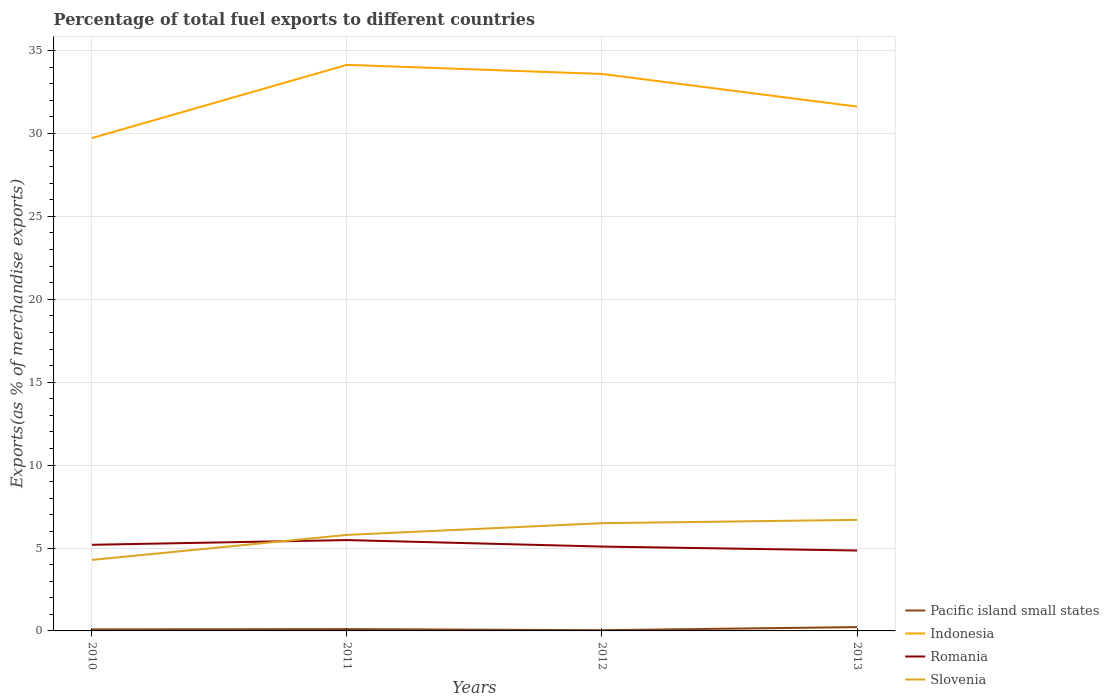Does the line corresponding to Slovenia intersect with the line corresponding to Indonesia?
Keep it short and to the point. No. Is the number of lines equal to the number of legend labels?
Ensure brevity in your answer.  Yes. Across all years, what is the maximum percentage of exports to different countries in Indonesia?
Your answer should be very brief. 29.73. What is the total percentage of exports to different countries in Slovenia in the graph?
Your response must be concise. -1.51. What is the difference between the highest and the second highest percentage of exports to different countries in Romania?
Provide a short and direct response. 0.63. Is the percentage of exports to different countries in Pacific island small states strictly greater than the percentage of exports to different countries in Slovenia over the years?
Offer a very short reply. Yes. How many years are there in the graph?
Keep it short and to the point. 4. Does the graph contain grids?
Provide a short and direct response. Yes. How are the legend labels stacked?
Your answer should be very brief. Vertical. What is the title of the graph?
Ensure brevity in your answer.  Percentage of total fuel exports to different countries. Does "Middle East & North Africa (developing only)" appear as one of the legend labels in the graph?
Ensure brevity in your answer.  No. What is the label or title of the Y-axis?
Give a very brief answer. Exports(as % of merchandise exports). What is the Exports(as % of merchandise exports) of Pacific island small states in 2010?
Offer a terse response. 0.09. What is the Exports(as % of merchandise exports) in Indonesia in 2010?
Your answer should be compact. 29.73. What is the Exports(as % of merchandise exports) of Romania in 2010?
Provide a short and direct response. 5.2. What is the Exports(as % of merchandise exports) in Slovenia in 2010?
Your response must be concise. 4.28. What is the Exports(as % of merchandise exports) in Pacific island small states in 2011?
Keep it short and to the point. 0.11. What is the Exports(as % of merchandise exports) in Indonesia in 2011?
Offer a terse response. 34.14. What is the Exports(as % of merchandise exports) in Romania in 2011?
Give a very brief answer. 5.48. What is the Exports(as % of merchandise exports) in Slovenia in 2011?
Give a very brief answer. 5.79. What is the Exports(as % of merchandise exports) of Pacific island small states in 2012?
Make the answer very short. 0.04. What is the Exports(as % of merchandise exports) of Indonesia in 2012?
Make the answer very short. 33.59. What is the Exports(as % of merchandise exports) of Romania in 2012?
Provide a short and direct response. 5.09. What is the Exports(as % of merchandise exports) in Slovenia in 2012?
Give a very brief answer. 6.5. What is the Exports(as % of merchandise exports) of Pacific island small states in 2013?
Give a very brief answer. 0.23. What is the Exports(as % of merchandise exports) of Indonesia in 2013?
Your answer should be compact. 31.62. What is the Exports(as % of merchandise exports) of Romania in 2013?
Give a very brief answer. 4.85. What is the Exports(as % of merchandise exports) in Slovenia in 2013?
Offer a terse response. 6.7. Across all years, what is the maximum Exports(as % of merchandise exports) in Pacific island small states?
Provide a succinct answer. 0.23. Across all years, what is the maximum Exports(as % of merchandise exports) in Indonesia?
Give a very brief answer. 34.14. Across all years, what is the maximum Exports(as % of merchandise exports) in Romania?
Make the answer very short. 5.48. Across all years, what is the maximum Exports(as % of merchandise exports) in Slovenia?
Your answer should be compact. 6.7. Across all years, what is the minimum Exports(as % of merchandise exports) in Pacific island small states?
Your answer should be very brief. 0.04. Across all years, what is the minimum Exports(as % of merchandise exports) in Indonesia?
Give a very brief answer. 29.73. Across all years, what is the minimum Exports(as % of merchandise exports) of Romania?
Your response must be concise. 4.85. Across all years, what is the minimum Exports(as % of merchandise exports) of Slovenia?
Provide a short and direct response. 4.28. What is the total Exports(as % of merchandise exports) of Pacific island small states in the graph?
Provide a short and direct response. 0.47. What is the total Exports(as % of merchandise exports) of Indonesia in the graph?
Your answer should be very brief. 129.08. What is the total Exports(as % of merchandise exports) in Romania in the graph?
Provide a short and direct response. 20.61. What is the total Exports(as % of merchandise exports) in Slovenia in the graph?
Offer a terse response. 23.27. What is the difference between the Exports(as % of merchandise exports) in Pacific island small states in 2010 and that in 2011?
Keep it short and to the point. -0.02. What is the difference between the Exports(as % of merchandise exports) in Indonesia in 2010 and that in 2011?
Ensure brevity in your answer.  -4.41. What is the difference between the Exports(as % of merchandise exports) in Romania in 2010 and that in 2011?
Your answer should be compact. -0.28. What is the difference between the Exports(as % of merchandise exports) in Slovenia in 2010 and that in 2011?
Ensure brevity in your answer.  -1.51. What is the difference between the Exports(as % of merchandise exports) of Pacific island small states in 2010 and that in 2012?
Provide a succinct answer. 0.05. What is the difference between the Exports(as % of merchandise exports) in Indonesia in 2010 and that in 2012?
Your answer should be compact. -3.86. What is the difference between the Exports(as % of merchandise exports) in Romania in 2010 and that in 2012?
Make the answer very short. 0.11. What is the difference between the Exports(as % of merchandise exports) of Slovenia in 2010 and that in 2012?
Make the answer very short. -2.21. What is the difference between the Exports(as % of merchandise exports) in Pacific island small states in 2010 and that in 2013?
Your answer should be compact. -0.14. What is the difference between the Exports(as % of merchandise exports) in Indonesia in 2010 and that in 2013?
Your response must be concise. -1.9. What is the difference between the Exports(as % of merchandise exports) of Romania in 2010 and that in 2013?
Offer a terse response. 0.35. What is the difference between the Exports(as % of merchandise exports) of Slovenia in 2010 and that in 2013?
Keep it short and to the point. -2.41. What is the difference between the Exports(as % of merchandise exports) of Pacific island small states in 2011 and that in 2012?
Keep it short and to the point. 0.07. What is the difference between the Exports(as % of merchandise exports) in Indonesia in 2011 and that in 2012?
Provide a succinct answer. 0.55. What is the difference between the Exports(as % of merchandise exports) in Romania in 2011 and that in 2012?
Offer a very short reply. 0.39. What is the difference between the Exports(as % of merchandise exports) in Slovenia in 2011 and that in 2012?
Your answer should be compact. -0.71. What is the difference between the Exports(as % of merchandise exports) in Pacific island small states in 2011 and that in 2013?
Your answer should be compact. -0.12. What is the difference between the Exports(as % of merchandise exports) in Indonesia in 2011 and that in 2013?
Provide a succinct answer. 2.52. What is the difference between the Exports(as % of merchandise exports) in Romania in 2011 and that in 2013?
Give a very brief answer. 0.63. What is the difference between the Exports(as % of merchandise exports) of Slovenia in 2011 and that in 2013?
Your response must be concise. -0.91. What is the difference between the Exports(as % of merchandise exports) of Pacific island small states in 2012 and that in 2013?
Provide a succinct answer. -0.19. What is the difference between the Exports(as % of merchandise exports) in Indonesia in 2012 and that in 2013?
Your response must be concise. 1.97. What is the difference between the Exports(as % of merchandise exports) in Romania in 2012 and that in 2013?
Your answer should be compact. 0.24. What is the difference between the Exports(as % of merchandise exports) in Slovenia in 2012 and that in 2013?
Offer a terse response. -0.2. What is the difference between the Exports(as % of merchandise exports) of Pacific island small states in 2010 and the Exports(as % of merchandise exports) of Indonesia in 2011?
Your answer should be compact. -34.05. What is the difference between the Exports(as % of merchandise exports) of Pacific island small states in 2010 and the Exports(as % of merchandise exports) of Romania in 2011?
Your answer should be very brief. -5.39. What is the difference between the Exports(as % of merchandise exports) in Pacific island small states in 2010 and the Exports(as % of merchandise exports) in Slovenia in 2011?
Ensure brevity in your answer.  -5.7. What is the difference between the Exports(as % of merchandise exports) of Indonesia in 2010 and the Exports(as % of merchandise exports) of Romania in 2011?
Provide a succinct answer. 24.25. What is the difference between the Exports(as % of merchandise exports) in Indonesia in 2010 and the Exports(as % of merchandise exports) in Slovenia in 2011?
Your answer should be compact. 23.94. What is the difference between the Exports(as % of merchandise exports) in Romania in 2010 and the Exports(as % of merchandise exports) in Slovenia in 2011?
Give a very brief answer. -0.6. What is the difference between the Exports(as % of merchandise exports) of Pacific island small states in 2010 and the Exports(as % of merchandise exports) of Indonesia in 2012?
Ensure brevity in your answer.  -33.5. What is the difference between the Exports(as % of merchandise exports) of Pacific island small states in 2010 and the Exports(as % of merchandise exports) of Romania in 2012?
Your answer should be compact. -5. What is the difference between the Exports(as % of merchandise exports) of Pacific island small states in 2010 and the Exports(as % of merchandise exports) of Slovenia in 2012?
Provide a succinct answer. -6.41. What is the difference between the Exports(as % of merchandise exports) in Indonesia in 2010 and the Exports(as % of merchandise exports) in Romania in 2012?
Offer a terse response. 24.64. What is the difference between the Exports(as % of merchandise exports) in Indonesia in 2010 and the Exports(as % of merchandise exports) in Slovenia in 2012?
Give a very brief answer. 23.23. What is the difference between the Exports(as % of merchandise exports) of Romania in 2010 and the Exports(as % of merchandise exports) of Slovenia in 2012?
Offer a terse response. -1.3. What is the difference between the Exports(as % of merchandise exports) in Pacific island small states in 2010 and the Exports(as % of merchandise exports) in Indonesia in 2013?
Offer a very short reply. -31.53. What is the difference between the Exports(as % of merchandise exports) in Pacific island small states in 2010 and the Exports(as % of merchandise exports) in Romania in 2013?
Offer a terse response. -4.76. What is the difference between the Exports(as % of merchandise exports) of Pacific island small states in 2010 and the Exports(as % of merchandise exports) of Slovenia in 2013?
Offer a terse response. -6.61. What is the difference between the Exports(as % of merchandise exports) in Indonesia in 2010 and the Exports(as % of merchandise exports) in Romania in 2013?
Keep it short and to the point. 24.88. What is the difference between the Exports(as % of merchandise exports) of Indonesia in 2010 and the Exports(as % of merchandise exports) of Slovenia in 2013?
Offer a terse response. 23.03. What is the difference between the Exports(as % of merchandise exports) in Romania in 2010 and the Exports(as % of merchandise exports) in Slovenia in 2013?
Provide a short and direct response. -1.5. What is the difference between the Exports(as % of merchandise exports) in Pacific island small states in 2011 and the Exports(as % of merchandise exports) in Indonesia in 2012?
Offer a very short reply. -33.48. What is the difference between the Exports(as % of merchandise exports) of Pacific island small states in 2011 and the Exports(as % of merchandise exports) of Romania in 2012?
Your answer should be very brief. -4.98. What is the difference between the Exports(as % of merchandise exports) of Pacific island small states in 2011 and the Exports(as % of merchandise exports) of Slovenia in 2012?
Make the answer very short. -6.39. What is the difference between the Exports(as % of merchandise exports) of Indonesia in 2011 and the Exports(as % of merchandise exports) of Romania in 2012?
Provide a short and direct response. 29.05. What is the difference between the Exports(as % of merchandise exports) of Indonesia in 2011 and the Exports(as % of merchandise exports) of Slovenia in 2012?
Your response must be concise. 27.64. What is the difference between the Exports(as % of merchandise exports) in Romania in 2011 and the Exports(as % of merchandise exports) in Slovenia in 2012?
Offer a terse response. -1.02. What is the difference between the Exports(as % of merchandise exports) in Pacific island small states in 2011 and the Exports(as % of merchandise exports) in Indonesia in 2013?
Your response must be concise. -31.51. What is the difference between the Exports(as % of merchandise exports) in Pacific island small states in 2011 and the Exports(as % of merchandise exports) in Romania in 2013?
Keep it short and to the point. -4.74. What is the difference between the Exports(as % of merchandise exports) in Pacific island small states in 2011 and the Exports(as % of merchandise exports) in Slovenia in 2013?
Keep it short and to the point. -6.59. What is the difference between the Exports(as % of merchandise exports) in Indonesia in 2011 and the Exports(as % of merchandise exports) in Romania in 2013?
Your answer should be very brief. 29.29. What is the difference between the Exports(as % of merchandise exports) of Indonesia in 2011 and the Exports(as % of merchandise exports) of Slovenia in 2013?
Ensure brevity in your answer.  27.44. What is the difference between the Exports(as % of merchandise exports) of Romania in 2011 and the Exports(as % of merchandise exports) of Slovenia in 2013?
Give a very brief answer. -1.22. What is the difference between the Exports(as % of merchandise exports) of Pacific island small states in 2012 and the Exports(as % of merchandise exports) of Indonesia in 2013?
Offer a very short reply. -31.58. What is the difference between the Exports(as % of merchandise exports) of Pacific island small states in 2012 and the Exports(as % of merchandise exports) of Romania in 2013?
Ensure brevity in your answer.  -4.81. What is the difference between the Exports(as % of merchandise exports) in Pacific island small states in 2012 and the Exports(as % of merchandise exports) in Slovenia in 2013?
Keep it short and to the point. -6.65. What is the difference between the Exports(as % of merchandise exports) in Indonesia in 2012 and the Exports(as % of merchandise exports) in Romania in 2013?
Make the answer very short. 28.74. What is the difference between the Exports(as % of merchandise exports) in Indonesia in 2012 and the Exports(as % of merchandise exports) in Slovenia in 2013?
Offer a terse response. 26.89. What is the difference between the Exports(as % of merchandise exports) of Romania in 2012 and the Exports(as % of merchandise exports) of Slovenia in 2013?
Provide a succinct answer. -1.61. What is the average Exports(as % of merchandise exports) in Pacific island small states per year?
Provide a succinct answer. 0.12. What is the average Exports(as % of merchandise exports) in Indonesia per year?
Your answer should be compact. 32.27. What is the average Exports(as % of merchandise exports) in Romania per year?
Give a very brief answer. 5.15. What is the average Exports(as % of merchandise exports) in Slovenia per year?
Offer a terse response. 5.82. In the year 2010, what is the difference between the Exports(as % of merchandise exports) of Pacific island small states and Exports(as % of merchandise exports) of Indonesia?
Keep it short and to the point. -29.64. In the year 2010, what is the difference between the Exports(as % of merchandise exports) in Pacific island small states and Exports(as % of merchandise exports) in Romania?
Your response must be concise. -5.11. In the year 2010, what is the difference between the Exports(as % of merchandise exports) of Pacific island small states and Exports(as % of merchandise exports) of Slovenia?
Your response must be concise. -4.19. In the year 2010, what is the difference between the Exports(as % of merchandise exports) of Indonesia and Exports(as % of merchandise exports) of Romania?
Your answer should be very brief. 24.53. In the year 2010, what is the difference between the Exports(as % of merchandise exports) of Indonesia and Exports(as % of merchandise exports) of Slovenia?
Offer a very short reply. 25.44. In the year 2010, what is the difference between the Exports(as % of merchandise exports) of Romania and Exports(as % of merchandise exports) of Slovenia?
Make the answer very short. 0.91. In the year 2011, what is the difference between the Exports(as % of merchandise exports) of Pacific island small states and Exports(as % of merchandise exports) of Indonesia?
Offer a terse response. -34.03. In the year 2011, what is the difference between the Exports(as % of merchandise exports) in Pacific island small states and Exports(as % of merchandise exports) in Romania?
Offer a very short reply. -5.37. In the year 2011, what is the difference between the Exports(as % of merchandise exports) of Pacific island small states and Exports(as % of merchandise exports) of Slovenia?
Your response must be concise. -5.68. In the year 2011, what is the difference between the Exports(as % of merchandise exports) of Indonesia and Exports(as % of merchandise exports) of Romania?
Your answer should be compact. 28.66. In the year 2011, what is the difference between the Exports(as % of merchandise exports) in Indonesia and Exports(as % of merchandise exports) in Slovenia?
Give a very brief answer. 28.35. In the year 2011, what is the difference between the Exports(as % of merchandise exports) of Romania and Exports(as % of merchandise exports) of Slovenia?
Your answer should be compact. -0.31. In the year 2012, what is the difference between the Exports(as % of merchandise exports) of Pacific island small states and Exports(as % of merchandise exports) of Indonesia?
Make the answer very short. -33.55. In the year 2012, what is the difference between the Exports(as % of merchandise exports) of Pacific island small states and Exports(as % of merchandise exports) of Romania?
Ensure brevity in your answer.  -5.04. In the year 2012, what is the difference between the Exports(as % of merchandise exports) of Pacific island small states and Exports(as % of merchandise exports) of Slovenia?
Offer a terse response. -6.45. In the year 2012, what is the difference between the Exports(as % of merchandise exports) of Indonesia and Exports(as % of merchandise exports) of Romania?
Provide a succinct answer. 28.5. In the year 2012, what is the difference between the Exports(as % of merchandise exports) in Indonesia and Exports(as % of merchandise exports) in Slovenia?
Offer a very short reply. 27.09. In the year 2012, what is the difference between the Exports(as % of merchandise exports) of Romania and Exports(as % of merchandise exports) of Slovenia?
Ensure brevity in your answer.  -1.41. In the year 2013, what is the difference between the Exports(as % of merchandise exports) of Pacific island small states and Exports(as % of merchandise exports) of Indonesia?
Ensure brevity in your answer.  -31.39. In the year 2013, what is the difference between the Exports(as % of merchandise exports) in Pacific island small states and Exports(as % of merchandise exports) in Romania?
Offer a terse response. -4.62. In the year 2013, what is the difference between the Exports(as % of merchandise exports) in Pacific island small states and Exports(as % of merchandise exports) in Slovenia?
Your answer should be very brief. -6.47. In the year 2013, what is the difference between the Exports(as % of merchandise exports) of Indonesia and Exports(as % of merchandise exports) of Romania?
Ensure brevity in your answer.  26.77. In the year 2013, what is the difference between the Exports(as % of merchandise exports) of Indonesia and Exports(as % of merchandise exports) of Slovenia?
Your response must be concise. 24.93. In the year 2013, what is the difference between the Exports(as % of merchandise exports) in Romania and Exports(as % of merchandise exports) in Slovenia?
Offer a very short reply. -1.85. What is the ratio of the Exports(as % of merchandise exports) in Pacific island small states in 2010 to that in 2011?
Keep it short and to the point. 0.82. What is the ratio of the Exports(as % of merchandise exports) of Indonesia in 2010 to that in 2011?
Offer a very short reply. 0.87. What is the ratio of the Exports(as % of merchandise exports) of Romania in 2010 to that in 2011?
Offer a very short reply. 0.95. What is the ratio of the Exports(as % of merchandise exports) of Slovenia in 2010 to that in 2011?
Make the answer very short. 0.74. What is the ratio of the Exports(as % of merchandise exports) of Pacific island small states in 2010 to that in 2012?
Ensure brevity in your answer.  2.11. What is the ratio of the Exports(as % of merchandise exports) in Indonesia in 2010 to that in 2012?
Ensure brevity in your answer.  0.89. What is the ratio of the Exports(as % of merchandise exports) of Romania in 2010 to that in 2012?
Your answer should be compact. 1.02. What is the ratio of the Exports(as % of merchandise exports) in Slovenia in 2010 to that in 2012?
Ensure brevity in your answer.  0.66. What is the ratio of the Exports(as % of merchandise exports) in Pacific island small states in 2010 to that in 2013?
Ensure brevity in your answer.  0.39. What is the ratio of the Exports(as % of merchandise exports) in Indonesia in 2010 to that in 2013?
Provide a succinct answer. 0.94. What is the ratio of the Exports(as % of merchandise exports) in Romania in 2010 to that in 2013?
Your response must be concise. 1.07. What is the ratio of the Exports(as % of merchandise exports) in Slovenia in 2010 to that in 2013?
Provide a short and direct response. 0.64. What is the ratio of the Exports(as % of merchandise exports) of Pacific island small states in 2011 to that in 2012?
Your answer should be compact. 2.58. What is the ratio of the Exports(as % of merchandise exports) of Indonesia in 2011 to that in 2012?
Give a very brief answer. 1.02. What is the ratio of the Exports(as % of merchandise exports) of Romania in 2011 to that in 2012?
Your answer should be very brief. 1.08. What is the ratio of the Exports(as % of merchandise exports) in Slovenia in 2011 to that in 2012?
Provide a short and direct response. 0.89. What is the ratio of the Exports(as % of merchandise exports) of Pacific island small states in 2011 to that in 2013?
Your answer should be very brief. 0.48. What is the ratio of the Exports(as % of merchandise exports) of Indonesia in 2011 to that in 2013?
Keep it short and to the point. 1.08. What is the ratio of the Exports(as % of merchandise exports) of Romania in 2011 to that in 2013?
Provide a short and direct response. 1.13. What is the ratio of the Exports(as % of merchandise exports) of Slovenia in 2011 to that in 2013?
Offer a terse response. 0.86. What is the ratio of the Exports(as % of merchandise exports) of Pacific island small states in 2012 to that in 2013?
Your answer should be compact. 0.19. What is the ratio of the Exports(as % of merchandise exports) in Indonesia in 2012 to that in 2013?
Offer a terse response. 1.06. What is the ratio of the Exports(as % of merchandise exports) in Romania in 2012 to that in 2013?
Your answer should be compact. 1.05. What is the ratio of the Exports(as % of merchandise exports) of Slovenia in 2012 to that in 2013?
Offer a terse response. 0.97. What is the difference between the highest and the second highest Exports(as % of merchandise exports) of Pacific island small states?
Provide a short and direct response. 0.12. What is the difference between the highest and the second highest Exports(as % of merchandise exports) of Indonesia?
Make the answer very short. 0.55. What is the difference between the highest and the second highest Exports(as % of merchandise exports) of Romania?
Your answer should be very brief. 0.28. What is the difference between the highest and the second highest Exports(as % of merchandise exports) in Slovenia?
Offer a terse response. 0.2. What is the difference between the highest and the lowest Exports(as % of merchandise exports) of Pacific island small states?
Offer a very short reply. 0.19. What is the difference between the highest and the lowest Exports(as % of merchandise exports) of Indonesia?
Give a very brief answer. 4.41. What is the difference between the highest and the lowest Exports(as % of merchandise exports) in Romania?
Your answer should be compact. 0.63. What is the difference between the highest and the lowest Exports(as % of merchandise exports) in Slovenia?
Give a very brief answer. 2.41. 